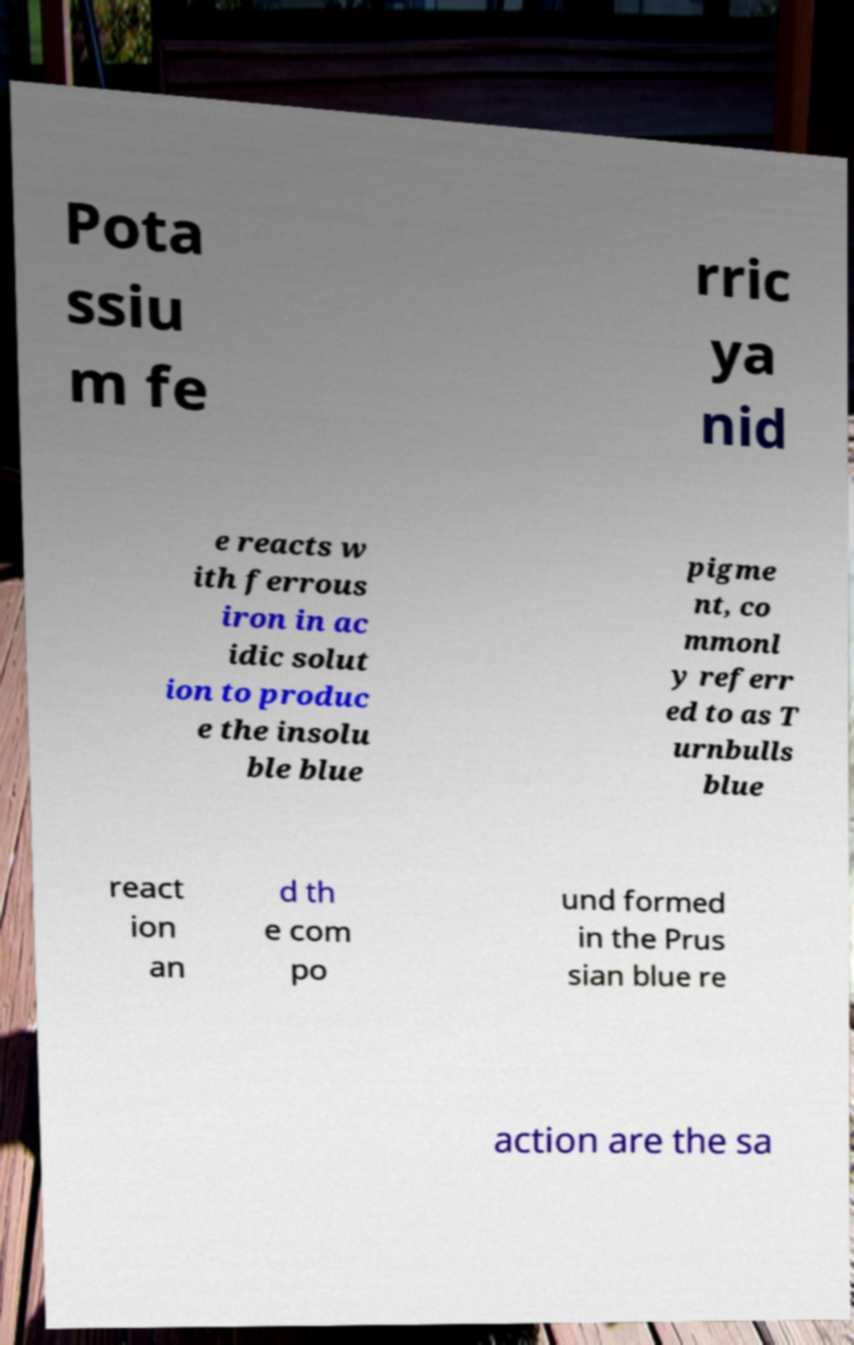Could you extract and type out the text from this image? Pota ssiu m fe rric ya nid e reacts w ith ferrous iron in ac idic solut ion to produc e the insolu ble blue pigme nt, co mmonl y referr ed to as T urnbulls blue react ion an d th e com po und formed in the Prus sian blue re action are the sa 